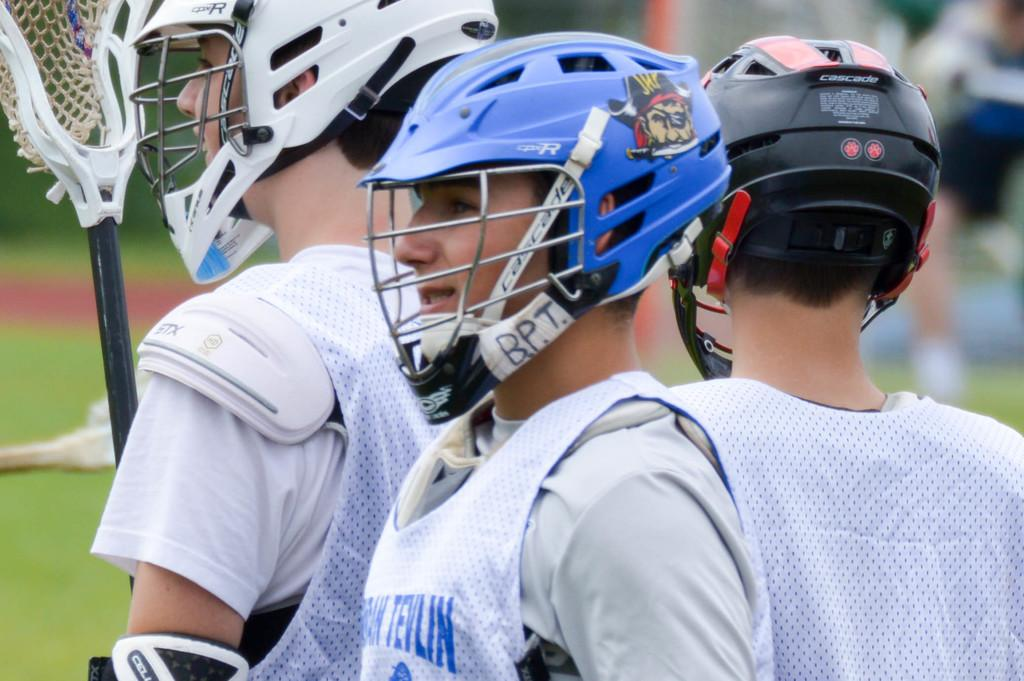How many people are in the image? There are three players in the image. What are the players wearing on their upper bodies? The players are wearing white color jackets. What protective gear are the players wearing on their heads? The players are wearing helmets. Can you describe the background of the image? The background of the image is blurred. What type of bird can be seen flapping its wings in the image? There is no bird present in the image, and therefore no wings can be observed. 